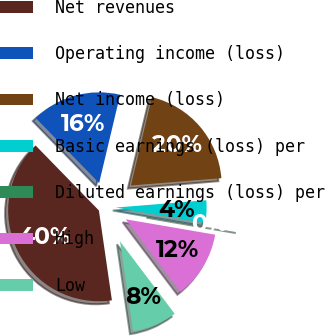Convert chart. <chart><loc_0><loc_0><loc_500><loc_500><pie_chart><fcel>Net revenues<fcel>Operating income (loss)<fcel>Net income (loss)<fcel>Basic earnings (loss) per<fcel>Diluted earnings (loss) per<fcel>High<fcel>Low<nl><fcel>40.0%<fcel>16.0%<fcel>20.0%<fcel>4.0%<fcel>0.0%<fcel>12.0%<fcel>8.0%<nl></chart> 